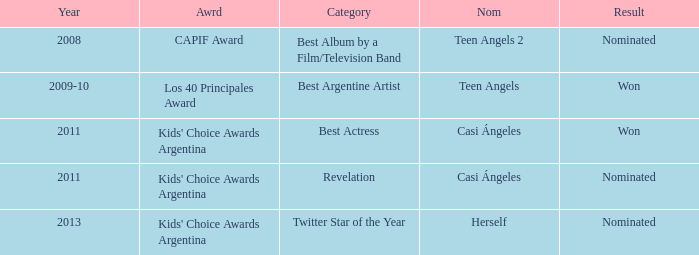In what category was Herself nominated? Twitter Star of the Year. 